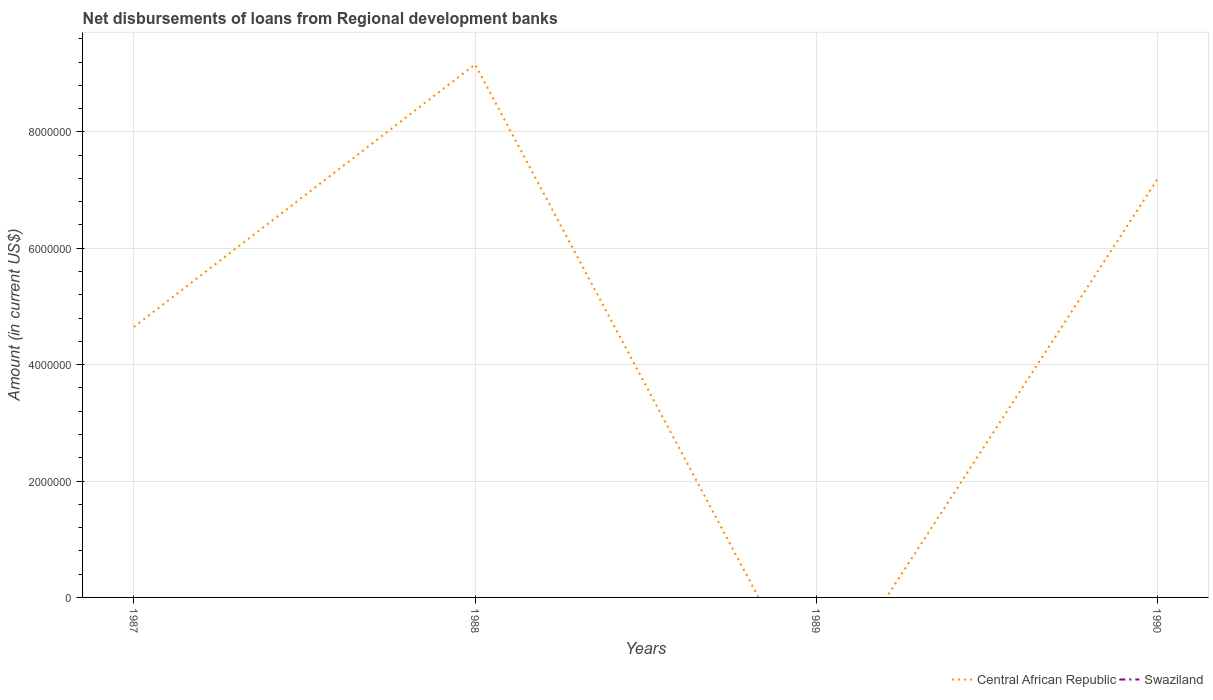Does the line corresponding to Central African Republic intersect with the line corresponding to Swaziland?
Make the answer very short. Yes. Is the number of lines equal to the number of legend labels?
Keep it short and to the point. No. What is the total amount of disbursements of loans from regional development banks in Central African Republic in the graph?
Ensure brevity in your answer.  -2.54e+06. What is the difference between the highest and the second highest amount of disbursements of loans from regional development banks in Central African Republic?
Provide a succinct answer. 9.16e+06. How many lines are there?
Make the answer very short. 1. Are the values on the major ticks of Y-axis written in scientific E-notation?
Your response must be concise. No. Where does the legend appear in the graph?
Give a very brief answer. Bottom right. How many legend labels are there?
Offer a terse response. 2. What is the title of the graph?
Keep it short and to the point. Net disbursements of loans from Regional development banks. Does "Tuvalu" appear as one of the legend labels in the graph?
Offer a terse response. No. What is the label or title of the X-axis?
Give a very brief answer. Years. What is the label or title of the Y-axis?
Your response must be concise. Amount (in current US$). What is the Amount (in current US$) in Central African Republic in 1987?
Give a very brief answer. 4.65e+06. What is the Amount (in current US$) of Swaziland in 1987?
Give a very brief answer. 0. What is the Amount (in current US$) in Central African Republic in 1988?
Provide a succinct answer. 9.16e+06. What is the Amount (in current US$) of Swaziland in 1988?
Make the answer very short. 0. What is the Amount (in current US$) of Central African Republic in 1989?
Give a very brief answer. 0. What is the Amount (in current US$) of Swaziland in 1989?
Provide a succinct answer. 0. What is the Amount (in current US$) of Central African Republic in 1990?
Keep it short and to the point. 7.18e+06. Across all years, what is the maximum Amount (in current US$) in Central African Republic?
Your answer should be very brief. 9.16e+06. Across all years, what is the minimum Amount (in current US$) in Central African Republic?
Provide a short and direct response. 0. What is the total Amount (in current US$) in Central African Republic in the graph?
Offer a terse response. 2.10e+07. What is the total Amount (in current US$) in Swaziland in the graph?
Your answer should be very brief. 0. What is the difference between the Amount (in current US$) of Central African Republic in 1987 and that in 1988?
Provide a short and direct response. -4.51e+06. What is the difference between the Amount (in current US$) of Central African Republic in 1987 and that in 1990?
Your answer should be very brief. -2.54e+06. What is the difference between the Amount (in current US$) in Central African Republic in 1988 and that in 1990?
Offer a very short reply. 1.98e+06. What is the average Amount (in current US$) of Central African Republic per year?
Offer a very short reply. 5.25e+06. What is the average Amount (in current US$) of Swaziland per year?
Your answer should be compact. 0. What is the ratio of the Amount (in current US$) of Central African Republic in 1987 to that in 1988?
Offer a terse response. 0.51. What is the ratio of the Amount (in current US$) in Central African Republic in 1987 to that in 1990?
Your answer should be very brief. 0.65. What is the ratio of the Amount (in current US$) of Central African Republic in 1988 to that in 1990?
Give a very brief answer. 1.28. What is the difference between the highest and the second highest Amount (in current US$) of Central African Republic?
Provide a succinct answer. 1.98e+06. What is the difference between the highest and the lowest Amount (in current US$) of Central African Republic?
Keep it short and to the point. 9.16e+06. 